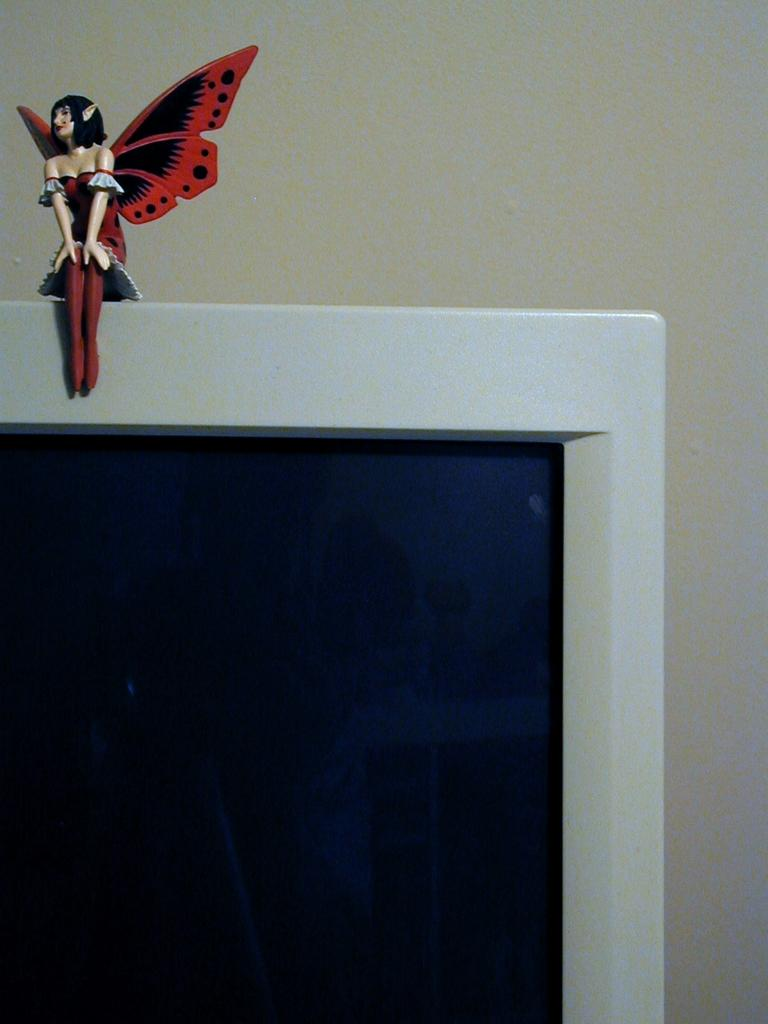What object is visible on the top of the screen in the image? There is a toy on the top of the screen in the image. What are the colors of the toy? The toy has black and red colors. What color is the background of the image? The background of the image is white. Can you see any women or giants stuck in quicksand in the image? No, there are no women, giants, or quicksand present in the image. 